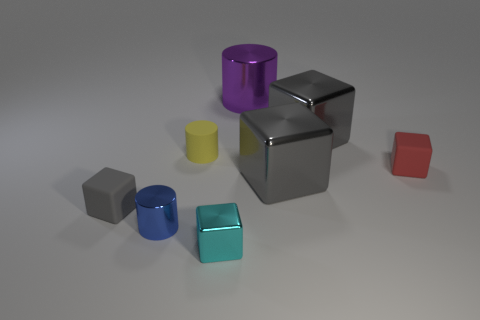How does the lighting affect the appearance of the objects? The lighting in the image creates a dramatic effect, casting soft shadows and highlighting the reflective qualities of the objects. The shiny surfaces of the silver cube, the purple cylinder, and the cyan cube reflect light dynamically, which accentuates their smooth textures and gives them a polished look. The matte surfaces of the remaining objects absorb light differently, giving them a more subdued appearance but still emphasizing their geometric forms. 